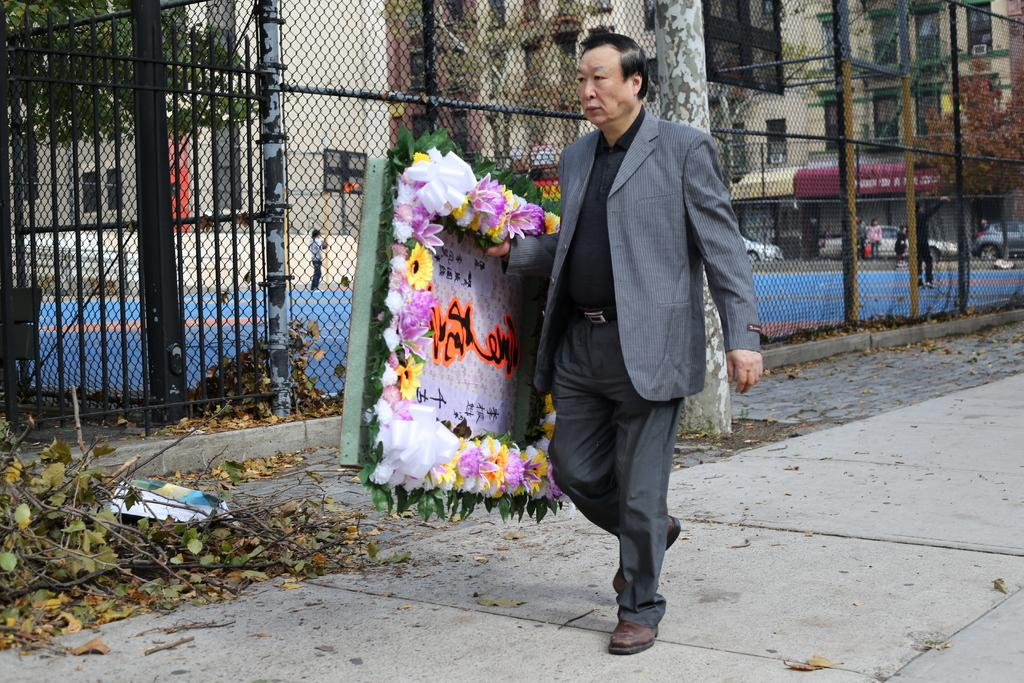What type of barrier can be seen in the image? There is a fence in the image. What is the man holding in the image? The man is holding a banner in the image. Can you describe the people in the image? There are people in the image. What type of vehicles are visible in the image? Cars are visible in the image. What type of structures can be seen in the image? There are buildings in the image. Can you tell me how many pancakes the farmer is holding in the image? There is no farmer or pancakes present in the image. What type of railway is visible in the image? There is no railway present in the image. 